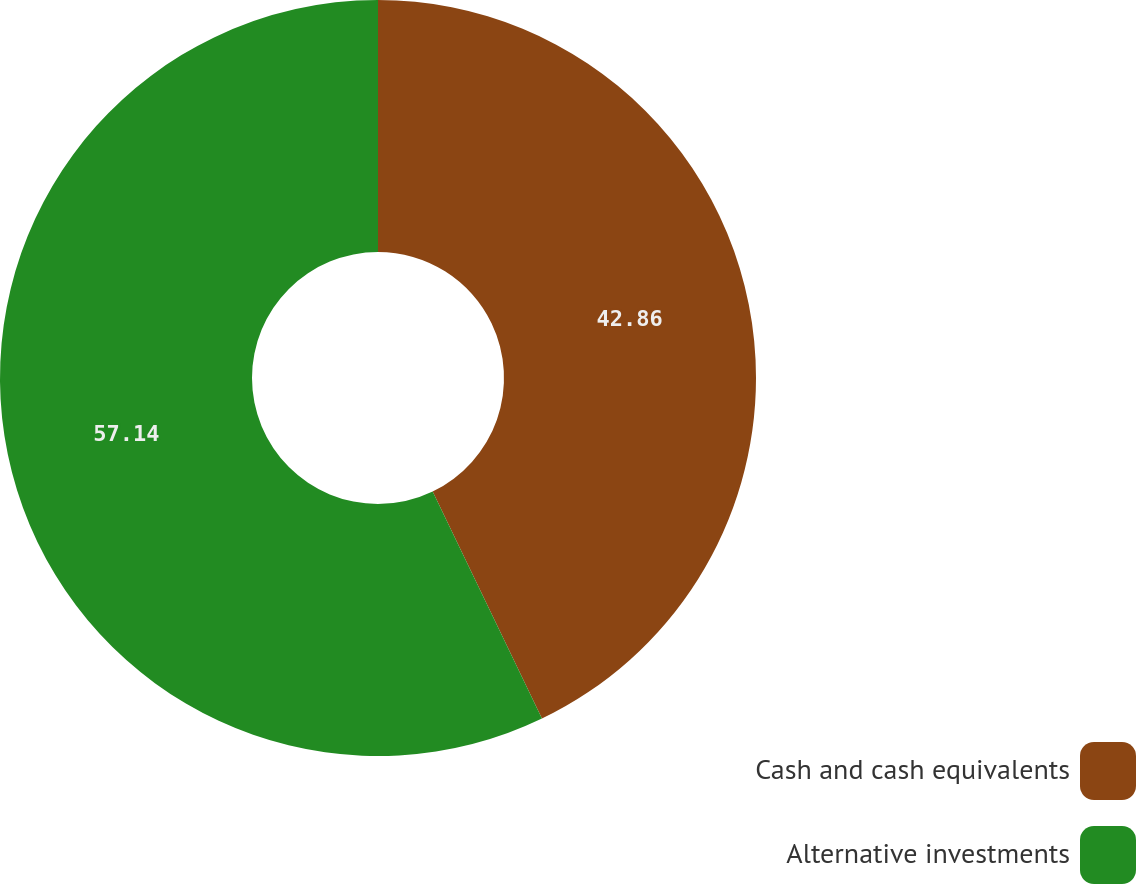<chart> <loc_0><loc_0><loc_500><loc_500><pie_chart><fcel>Cash and cash equivalents<fcel>Alternative investments<nl><fcel>42.86%<fcel>57.14%<nl></chart> 